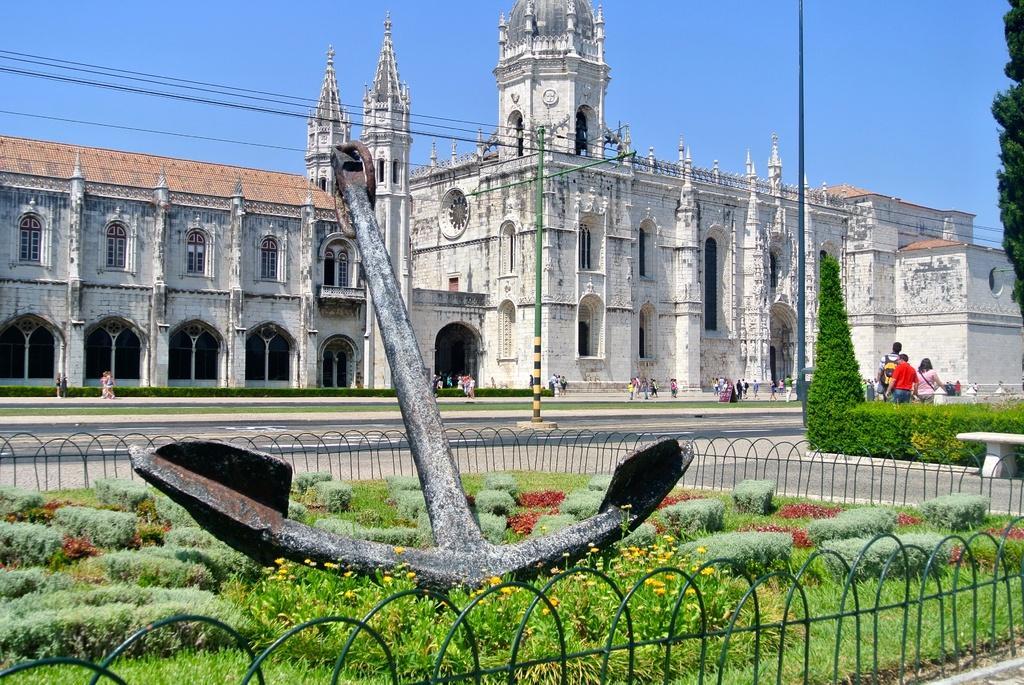Could you give a brief overview of what you see in this image? In this image, we can see the ground. We can see some grass, plants and a metallic object. There are a few people. We can also see a bench on the right. There are a few trees. We can also see a building. We can see some poles with wires. We can see the sky. We can see the fence. 